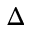Convert formula to latex. <formula><loc_0><loc_0><loc_500><loc_500>\Delta</formula> 